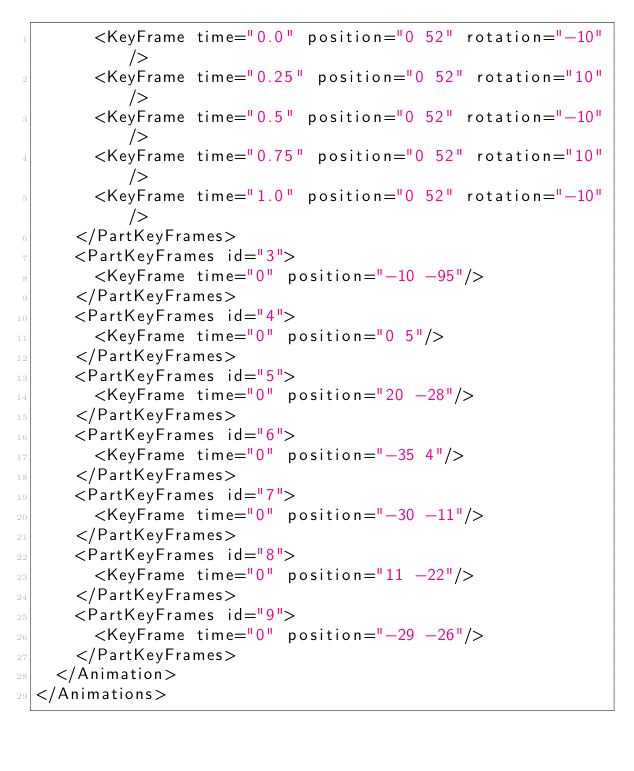Convert code to text. <code><loc_0><loc_0><loc_500><loc_500><_XML_>			<KeyFrame time="0.0" position="0 52" rotation="-10"/>
			<KeyFrame time="0.25" position="0 52" rotation="10"/>
			<KeyFrame time="0.5" position="0 52" rotation="-10"/>
			<KeyFrame time="0.75" position="0 52" rotation="10"/>
			<KeyFrame time="1.0" position="0 52" rotation="-10"/>
		</PartKeyFrames>
		<PartKeyFrames id="3">
			<KeyFrame time="0" position="-10 -95"/>
		</PartKeyFrames>
		<PartKeyFrames id="4">
			<KeyFrame time="0" position="0 5"/>
		</PartKeyFrames>
		<PartKeyFrames id="5">
			<KeyFrame time="0" position="20 -28"/>
		</PartKeyFrames>
		<PartKeyFrames id="6">
			<KeyFrame time="0" position="-35 4"/>
		</PartKeyFrames>
		<PartKeyFrames id="7">
			<KeyFrame time="0" position="-30 -11"/>
		</PartKeyFrames>
		<PartKeyFrames id="8">
			<KeyFrame time="0" position="11 -22"/>
		</PartKeyFrames>
		<PartKeyFrames id="9">
			<KeyFrame time="0" position="-29 -26"/>
		</PartKeyFrames>
	</Animation>
</Animations>
</code> 